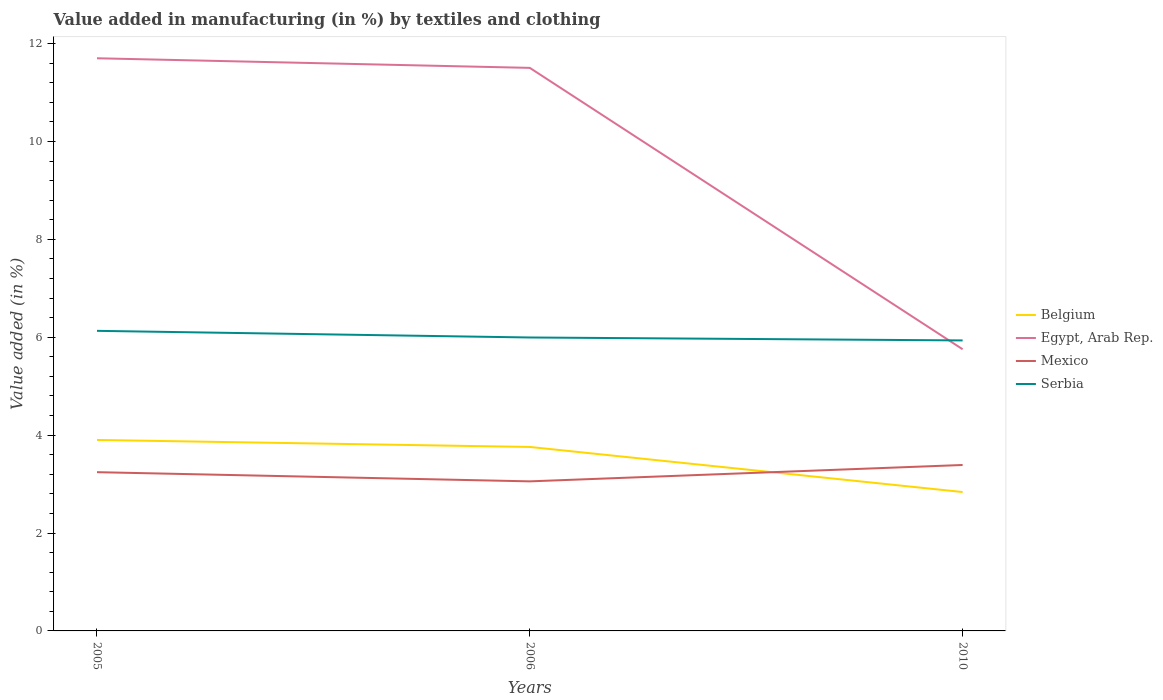How many different coloured lines are there?
Provide a succinct answer. 4. Is the number of lines equal to the number of legend labels?
Your answer should be very brief. Yes. Across all years, what is the maximum percentage of value added in manufacturing by textiles and clothing in Egypt, Arab Rep.?
Ensure brevity in your answer.  5.75. In which year was the percentage of value added in manufacturing by textiles and clothing in Belgium maximum?
Offer a terse response. 2010. What is the total percentage of value added in manufacturing by textiles and clothing in Mexico in the graph?
Make the answer very short. -0.15. What is the difference between the highest and the second highest percentage of value added in manufacturing by textiles and clothing in Belgium?
Your response must be concise. 1.06. Is the percentage of value added in manufacturing by textiles and clothing in Mexico strictly greater than the percentage of value added in manufacturing by textiles and clothing in Belgium over the years?
Your response must be concise. No. What is the difference between two consecutive major ticks on the Y-axis?
Keep it short and to the point. 2. Does the graph contain grids?
Offer a very short reply. No. How many legend labels are there?
Your answer should be compact. 4. What is the title of the graph?
Your answer should be compact. Value added in manufacturing (in %) by textiles and clothing. What is the label or title of the Y-axis?
Give a very brief answer. Value added (in %). What is the Value added (in %) of Belgium in 2005?
Your answer should be compact. 3.9. What is the Value added (in %) of Egypt, Arab Rep. in 2005?
Ensure brevity in your answer.  11.7. What is the Value added (in %) in Mexico in 2005?
Provide a short and direct response. 3.24. What is the Value added (in %) in Serbia in 2005?
Your response must be concise. 6.13. What is the Value added (in %) of Belgium in 2006?
Ensure brevity in your answer.  3.76. What is the Value added (in %) of Egypt, Arab Rep. in 2006?
Keep it short and to the point. 11.5. What is the Value added (in %) of Mexico in 2006?
Provide a succinct answer. 3.06. What is the Value added (in %) of Serbia in 2006?
Ensure brevity in your answer.  6. What is the Value added (in %) of Belgium in 2010?
Your answer should be compact. 2.84. What is the Value added (in %) in Egypt, Arab Rep. in 2010?
Provide a short and direct response. 5.75. What is the Value added (in %) of Mexico in 2010?
Offer a terse response. 3.39. What is the Value added (in %) in Serbia in 2010?
Give a very brief answer. 5.94. Across all years, what is the maximum Value added (in %) in Belgium?
Your answer should be compact. 3.9. Across all years, what is the maximum Value added (in %) in Egypt, Arab Rep.?
Your response must be concise. 11.7. Across all years, what is the maximum Value added (in %) in Mexico?
Your answer should be very brief. 3.39. Across all years, what is the maximum Value added (in %) in Serbia?
Make the answer very short. 6.13. Across all years, what is the minimum Value added (in %) in Belgium?
Provide a succinct answer. 2.84. Across all years, what is the minimum Value added (in %) of Egypt, Arab Rep.?
Give a very brief answer. 5.75. Across all years, what is the minimum Value added (in %) in Mexico?
Offer a terse response. 3.06. Across all years, what is the minimum Value added (in %) of Serbia?
Give a very brief answer. 5.94. What is the total Value added (in %) in Belgium in the graph?
Offer a very short reply. 10.5. What is the total Value added (in %) in Egypt, Arab Rep. in the graph?
Your answer should be very brief. 28.96. What is the total Value added (in %) of Mexico in the graph?
Your response must be concise. 9.69. What is the total Value added (in %) in Serbia in the graph?
Provide a short and direct response. 18.06. What is the difference between the Value added (in %) of Belgium in 2005 and that in 2006?
Offer a very short reply. 0.14. What is the difference between the Value added (in %) of Egypt, Arab Rep. in 2005 and that in 2006?
Keep it short and to the point. 0.2. What is the difference between the Value added (in %) of Mexico in 2005 and that in 2006?
Keep it short and to the point. 0.19. What is the difference between the Value added (in %) in Serbia in 2005 and that in 2006?
Offer a very short reply. 0.14. What is the difference between the Value added (in %) of Belgium in 2005 and that in 2010?
Offer a terse response. 1.06. What is the difference between the Value added (in %) in Egypt, Arab Rep. in 2005 and that in 2010?
Your answer should be very brief. 5.95. What is the difference between the Value added (in %) in Mexico in 2005 and that in 2010?
Make the answer very short. -0.15. What is the difference between the Value added (in %) of Serbia in 2005 and that in 2010?
Provide a short and direct response. 0.2. What is the difference between the Value added (in %) of Belgium in 2006 and that in 2010?
Your answer should be very brief. 0.92. What is the difference between the Value added (in %) in Egypt, Arab Rep. in 2006 and that in 2010?
Give a very brief answer. 5.75. What is the difference between the Value added (in %) of Mexico in 2006 and that in 2010?
Offer a very short reply. -0.33. What is the difference between the Value added (in %) of Serbia in 2006 and that in 2010?
Give a very brief answer. 0.06. What is the difference between the Value added (in %) in Belgium in 2005 and the Value added (in %) in Egypt, Arab Rep. in 2006?
Make the answer very short. -7.6. What is the difference between the Value added (in %) of Belgium in 2005 and the Value added (in %) of Mexico in 2006?
Offer a very short reply. 0.85. What is the difference between the Value added (in %) of Belgium in 2005 and the Value added (in %) of Serbia in 2006?
Make the answer very short. -2.09. What is the difference between the Value added (in %) of Egypt, Arab Rep. in 2005 and the Value added (in %) of Mexico in 2006?
Your answer should be very brief. 8.64. What is the difference between the Value added (in %) of Egypt, Arab Rep. in 2005 and the Value added (in %) of Serbia in 2006?
Give a very brief answer. 5.7. What is the difference between the Value added (in %) in Mexico in 2005 and the Value added (in %) in Serbia in 2006?
Provide a short and direct response. -2.75. What is the difference between the Value added (in %) of Belgium in 2005 and the Value added (in %) of Egypt, Arab Rep. in 2010?
Offer a terse response. -1.85. What is the difference between the Value added (in %) of Belgium in 2005 and the Value added (in %) of Mexico in 2010?
Give a very brief answer. 0.51. What is the difference between the Value added (in %) of Belgium in 2005 and the Value added (in %) of Serbia in 2010?
Keep it short and to the point. -2.03. What is the difference between the Value added (in %) of Egypt, Arab Rep. in 2005 and the Value added (in %) of Mexico in 2010?
Provide a short and direct response. 8.31. What is the difference between the Value added (in %) of Egypt, Arab Rep. in 2005 and the Value added (in %) of Serbia in 2010?
Provide a short and direct response. 5.76. What is the difference between the Value added (in %) in Mexico in 2005 and the Value added (in %) in Serbia in 2010?
Ensure brevity in your answer.  -2.69. What is the difference between the Value added (in %) of Belgium in 2006 and the Value added (in %) of Egypt, Arab Rep. in 2010?
Keep it short and to the point. -2. What is the difference between the Value added (in %) in Belgium in 2006 and the Value added (in %) in Mexico in 2010?
Ensure brevity in your answer.  0.37. What is the difference between the Value added (in %) of Belgium in 2006 and the Value added (in %) of Serbia in 2010?
Your answer should be compact. -2.18. What is the difference between the Value added (in %) in Egypt, Arab Rep. in 2006 and the Value added (in %) in Mexico in 2010?
Give a very brief answer. 8.11. What is the difference between the Value added (in %) of Egypt, Arab Rep. in 2006 and the Value added (in %) of Serbia in 2010?
Your response must be concise. 5.57. What is the difference between the Value added (in %) of Mexico in 2006 and the Value added (in %) of Serbia in 2010?
Ensure brevity in your answer.  -2.88. What is the average Value added (in %) of Belgium per year?
Make the answer very short. 3.5. What is the average Value added (in %) of Egypt, Arab Rep. per year?
Your answer should be compact. 9.65. What is the average Value added (in %) of Mexico per year?
Ensure brevity in your answer.  3.23. What is the average Value added (in %) of Serbia per year?
Keep it short and to the point. 6.02. In the year 2005, what is the difference between the Value added (in %) of Belgium and Value added (in %) of Egypt, Arab Rep.?
Your answer should be very brief. -7.8. In the year 2005, what is the difference between the Value added (in %) of Belgium and Value added (in %) of Mexico?
Provide a short and direct response. 0.66. In the year 2005, what is the difference between the Value added (in %) of Belgium and Value added (in %) of Serbia?
Offer a very short reply. -2.23. In the year 2005, what is the difference between the Value added (in %) of Egypt, Arab Rep. and Value added (in %) of Mexico?
Your answer should be very brief. 8.46. In the year 2005, what is the difference between the Value added (in %) of Egypt, Arab Rep. and Value added (in %) of Serbia?
Give a very brief answer. 5.57. In the year 2005, what is the difference between the Value added (in %) in Mexico and Value added (in %) in Serbia?
Ensure brevity in your answer.  -2.89. In the year 2006, what is the difference between the Value added (in %) of Belgium and Value added (in %) of Egypt, Arab Rep.?
Your response must be concise. -7.74. In the year 2006, what is the difference between the Value added (in %) in Belgium and Value added (in %) in Mexico?
Provide a short and direct response. 0.7. In the year 2006, what is the difference between the Value added (in %) in Belgium and Value added (in %) in Serbia?
Offer a terse response. -2.24. In the year 2006, what is the difference between the Value added (in %) of Egypt, Arab Rep. and Value added (in %) of Mexico?
Offer a terse response. 8.45. In the year 2006, what is the difference between the Value added (in %) in Egypt, Arab Rep. and Value added (in %) in Serbia?
Make the answer very short. 5.51. In the year 2006, what is the difference between the Value added (in %) in Mexico and Value added (in %) in Serbia?
Your answer should be compact. -2.94. In the year 2010, what is the difference between the Value added (in %) in Belgium and Value added (in %) in Egypt, Arab Rep.?
Provide a short and direct response. -2.92. In the year 2010, what is the difference between the Value added (in %) of Belgium and Value added (in %) of Mexico?
Keep it short and to the point. -0.55. In the year 2010, what is the difference between the Value added (in %) of Belgium and Value added (in %) of Serbia?
Your response must be concise. -3.1. In the year 2010, what is the difference between the Value added (in %) of Egypt, Arab Rep. and Value added (in %) of Mexico?
Provide a succinct answer. 2.36. In the year 2010, what is the difference between the Value added (in %) of Egypt, Arab Rep. and Value added (in %) of Serbia?
Offer a very short reply. -0.18. In the year 2010, what is the difference between the Value added (in %) of Mexico and Value added (in %) of Serbia?
Make the answer very short. -2.55. What is the ratio of the Value added (in %) of Belgium in 2005 to that in 2006?
Give a very brief answer. 1.04. What is the ratio of the Value added (in %) of Egypt, Arab Rep. in 2005 to that in 2006?
Offer a very short reply. 1.02. What is the ratio of the Value added (in %) in Mexico in 2005 to that in 2006?
Ensure brevity in your answer.  1.06. What is the ratio of the Value added (in %) of Serbia in 2005 to that in 2006?
Offer a very short reply. 1.02. What is the ratio of the Value added (in %) in Belgium in 2005 to that in 2010?
Your response must be concise. 1.38. What is the ratio of the Value added (in %) of Egypt, Arab Rep. in 2005 to that in 2010?
Provide a succinct answer. 2.03. What is the ratio of the Value added (in %) of Mexico in 2005 to that in 2010?
Your answer should be very brief. 0.96. What is the ratio of the Value added (in %) of Serbia in 2005 to that in 2010?
Your answer should be compact. 1.03. What is the ratio of the Value added (in %) in Belgium in 2006 to that in 2010?
Ensure brevity in your answer.  1.32. What is the ratio of the Value added (in %) in Egypt, Arab Rep. in 2006 to that in 2010?
Provide a succinct answer. 2. What is the ratio of the Value added (in %) in Mexico in 2006 to that in 2010?
Your response must be concise. 0.9. What is the ratio of the Value added (in %) in Serbia in 2006 to that in 2010?
Ensure brevity in your answer.  1.01. What is the difference between the highest and the second highest Value added (in %) of Belgium?
Give a very brief answer. 0.14. What is the difference between the highest and the second highest Value added (in %) in Egypt, Arab Rep.?
Your response must be concise. 0.2. What is the difference between the highest and the second highest Value added (in %) of Mexico?
Keep it short and to the point. 0.15. What is the difference between the highest and the second highest Value added (in %) in Serbia?
Offer a very short reply. 0.14. What is the difference between the highest and the lowest Value added (in %) of Belgium?
Your answer should be compact. 1.06. What is the difference between the highest and the lowest Value added (in %) of Egypt, Arab Rep.?
Keep it short and to the point. 5.95. What is the difference between the highest and the lowest Value added (in %) in Mexico?
Your answer should be very brief. 0.33. What is the difference between the highest and the lowest Value added (in %) of Serbia?
Provide a short and direct response. 0.2. 